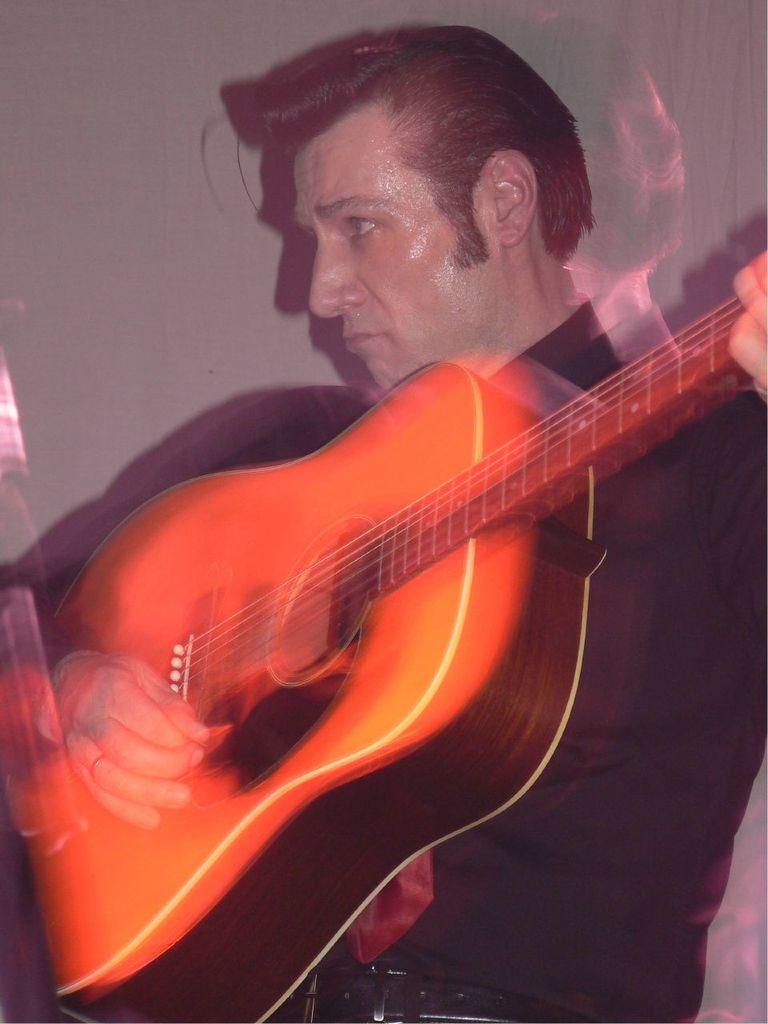In one or two sentences, can you explain what this image depicts? A man is playing a guitar in his hands. 